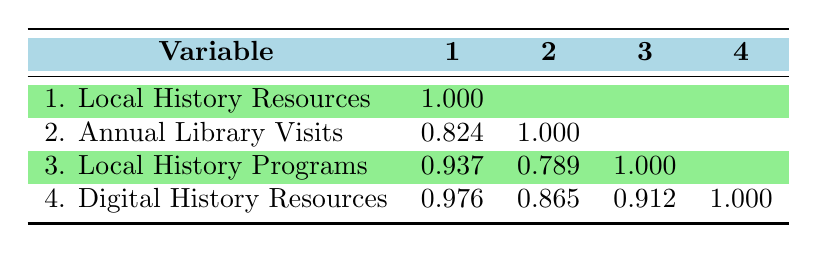What is the correlation between Local History Resources and Annual Library Visits? The table shows that the correlation coefficient between Local History Resources and Annual Library Visits is 0.824, indicating a strong positive relationship.
Answer: 0.824 Which library has the highest number of Local History Programs Offered? By examining the table, Chicago Public Library has the highest number of Local History Programs Offered at 75.
Answer: 75 Is there a correlation between Digital History Resources and Local History Programs Offered? The correlation coefficient between Digital History Resources and Local History Programs Offered is 0.912, which indicates a very strong positive relationship.
Answer: Yes What is the average number of Digital History Resources across all libraries listed? To calculate the average, we sum the Digital History Resources available (1500 + 800 + 950 + 500 + 700 + 600 = 4100) and divide by the number of libraries (6). Thus the average is 4100/6 = 683.33.
Answer: 683.33 How much more Local History Resources does the Chicago Public Library have compared to the Rockford Public Library? Chicago Public Library has 30 Local History Resources while Rockford Public Library has 10. The difference is 30 - 10 = 20.
Answer: 20 Is the correlation coefficient between Annual Library Visits and Local History Resources lower than 0.9? The correlation coefficient between Annual Library Visits and Local History Resources is 0.824, which is indeed lower than 0.9.
Answer: Yes Does the Springfield Public Library have more Digital History Resources than the Naperville Public Library? Springfield Public Library has 800 Digital History Resources, while Naperville Public Library has 700. Since 800 is greater than 700, Springfield does have more.
Answer: Yes What is the total number of Local History Programs Offered by all libraries combined? By summing the Local History Programs Offered (75 + 40 + 30 + 20 + 25 + 15 = 235), the total is calculated as 235.
Answer: 235 Between the highest and lowest library visits, what is the difference in the number of Annual Library Visits? The library with the highest visits is Chicago Public Library with 1200000 visits, while the lowest is Evanston Public Library with 150000 visits. The difference is 1200000 - 150000 = 1050000.
Answer: 1050000 